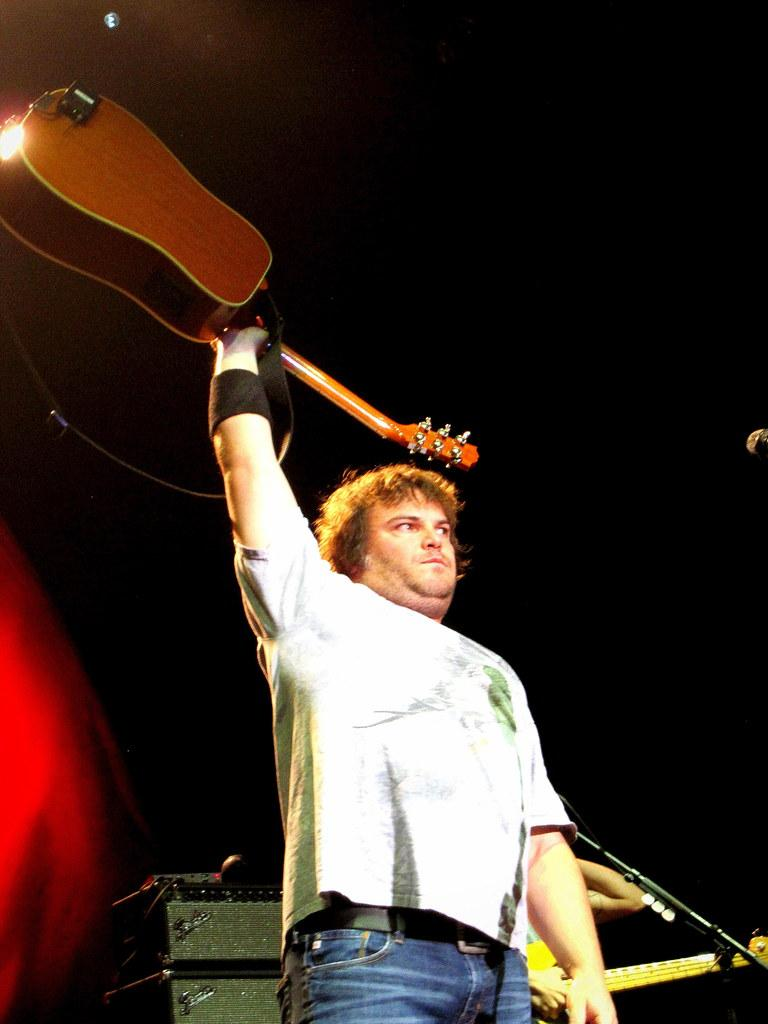What is the main subject of the image? The main subject of the image is a man. What is the man doing in the image? The man is standing in the image. What object is the man holding? The man is holding a guitar. What type of clothing is the man wearing? The man is wearing a t-shirt and blue pants. What other objects are present in the image? There is a microphone and a light in the image. Can you see any islands in the image? There are no islands present in the image. Is the man holding a bone in the image? There is no bone present in the image. 